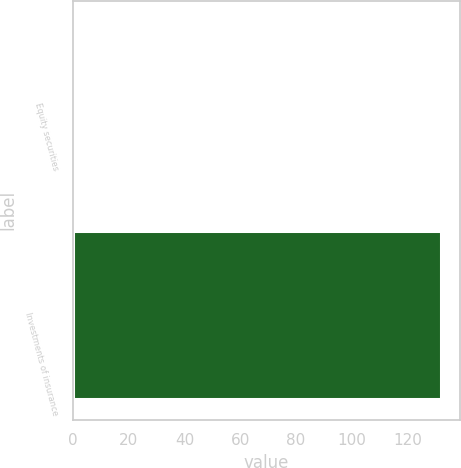<chart> <loc_0><loc_0><loc_500><loc_500><bar_chart><fcel>Equity securities<fcel>Investments of insurance<nl><fcel>1<fcel>132<nl></chart> 